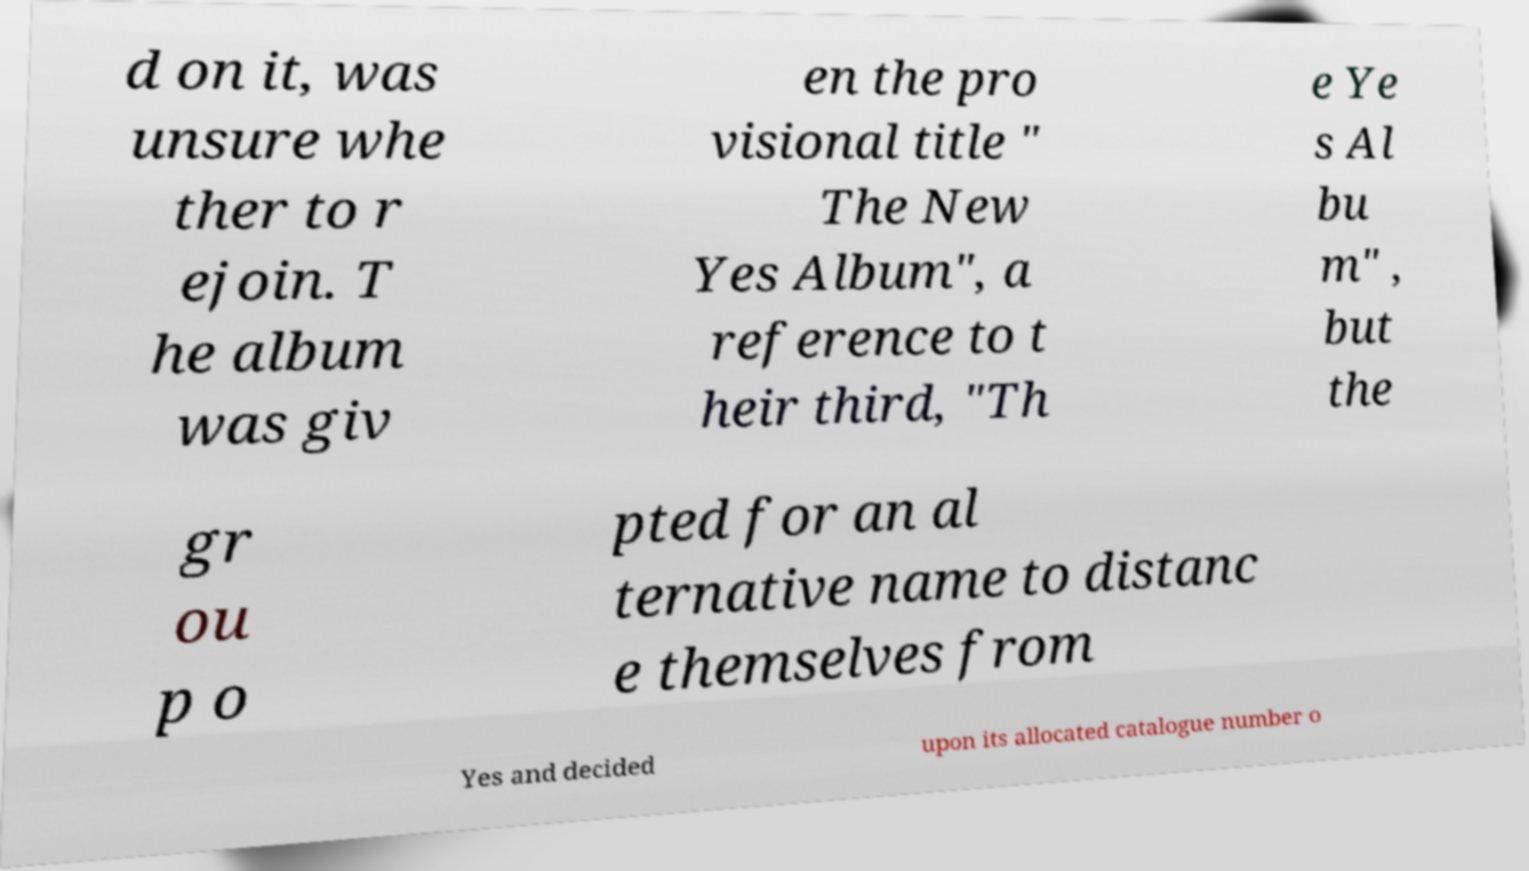Please read and relay the text visible in this image. What does it say? d on it, was unsure whe ther to r ejoin. T he album was giv en the pro visional title " The New Yes Album", a reference to t heir third, "Th e Ye s Al bu m" , but the gr ou p o pted for an al ternative name to distanc e themselves from Yes and decided upon its allocated catalogue number o 